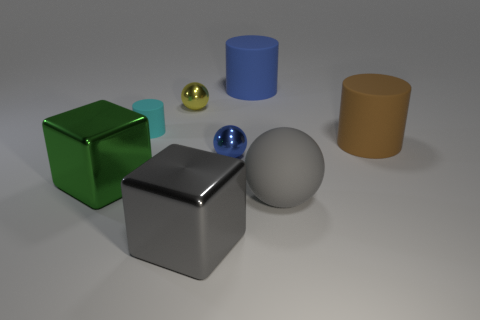Subtract all yellow cylinders. Subtract all blue blocks. How many cylinders are left? 3 Add 1 big yellow shiny blocks. How many objects exist? 9 Subtract all spheres. How many objects are left? 5 Add 6 large yellow shiny blocks. How many large yellow shiny blocks exist? 6 Subtract 0 purple spheres. How many objects are left? 8 Subtract all metal spheres. Subtract all green rubber things. How many objects are left? 6 Add 8 tiny cyan cylinders. How many tiny cyan cylinders are left? 9 